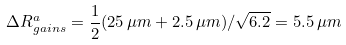<formula> <loc_0><loc_0><loc_500><loc_500>\Delta R _ { g a i n s } ^ { a } = \frac { 1 } { 2 } ( 2 5 \, \mu { m } + 2 . 5 \, \mu { m } ) / \sqrt { 6 . 2 } = 5 . 5 \, \mu { m }</formula> 